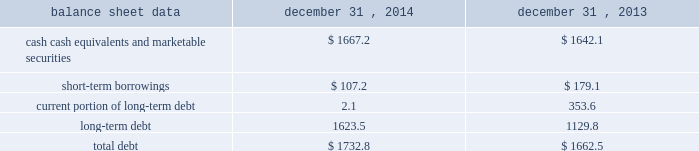Management 2019s discussion and analysis of financial condition and results of operations 2013 ( continued ) ( amounts in millions , except per share amounts ) net cash used in investing activities during 2013 primarily related to payments for capital expenditures and acquisitions .
Capital expenditures of $ 173.0 related primarily to computer hardware and software and leasehold improvements .
We made payments of $ 61.5 related to acquisitions completed during 2013 , net of cash acquired .
Financing activities net cash used in financing activities during 2014 primarily related to the purchase of long-term debt , the repurchase of our common stock and payment of dividends .
During 2014 , we redeemed all $ 350.0 in aggregate principal amount of the 6.25% ( 6.25 % ) notes , repurchased 14.9 shares of our common stock for an aggregate cost of $ 275.1 , including fees , and made dividend payments of $ 159.0 on our common stock .
This was offset by the issuance of $ 500.0 in aggregate principal amount of our 4.20% ( 4.20 % ) notes .
Net cash used in financing activities during 2013 primarily related to the purchase of long-term debt , the repurchase of our common stock and payment of dividends .
We redeemed all $ 600.0 in aggregate principal amount of our 10.00% ( 10.00 % ) notes .
In addition , we repurchased 31.8 shares of our common stock for an aggregate cost of $ 481.8 , including fees , and made dividend payments of $ 126.0 on our common stock .
Foreign exchange rate changes the effect of foreign exchange rate changes on cash and cash equivalents included in the consolidated statements of cash flows resulted in a decrease of $ 101.0 in 2014 .
The decrease was primarily a result of the u.s .
Dollar being stronger than several foreign currencies , including the canadian dollar , brazilian real , australian dollar and the euro as of december 31 , 2014 compared to december 31 , 2013 .
The effect of foreign exchange rate changes on cash and cash equivalents included in the consolidated statements of cash flows resulted in a decrease of $ 94.1 in 2013 .
The decrease was primarily a result of the u.s .
Dollar being stronger than several foreign currencies , including the australian dollar , brazilian real , canadian dollar , japanese yen , and south african rand as of december 31 , 2013 compared to december 31 , 2012. .
Liquidity outlook we expect our cash flow from operations , cash and cash equivalents to be sufficient to meet our anticipated operating requirements at a minimum for the next twelve months .
We also have a committed corporate credit facility as well as uncommitted facilities available to support our operating needs .
We continue to maintain a disciplined approach to managing liquidity , with flexibility over significant uses of cash , including our capital expenditures , cash used for new acquisitions , our common stock repurchase program and our common stock dividends .
From time to time , we evaluate market conditions and financing alternatives for opportunities to raise additional funds or otherwise improve our liquidity profile , enhance our financial flexibility and manage market risk .
Our ability to access the capital markets depends on a number of factors , which include those specific to us , such as our credit rating , and those related to the financial markets , such as the amount or terms of available credit .
There can be no guarantee that we would be able to access new sources of liquidity on commercially reasonable terms , or at all. .
What percentage of total debt is from long-term debt , from 2013-2014? 
Computations: (((1623.5 + 1129.8) / (1732.8 + 1662.5)) * 100)
Answer: 81.09151. 